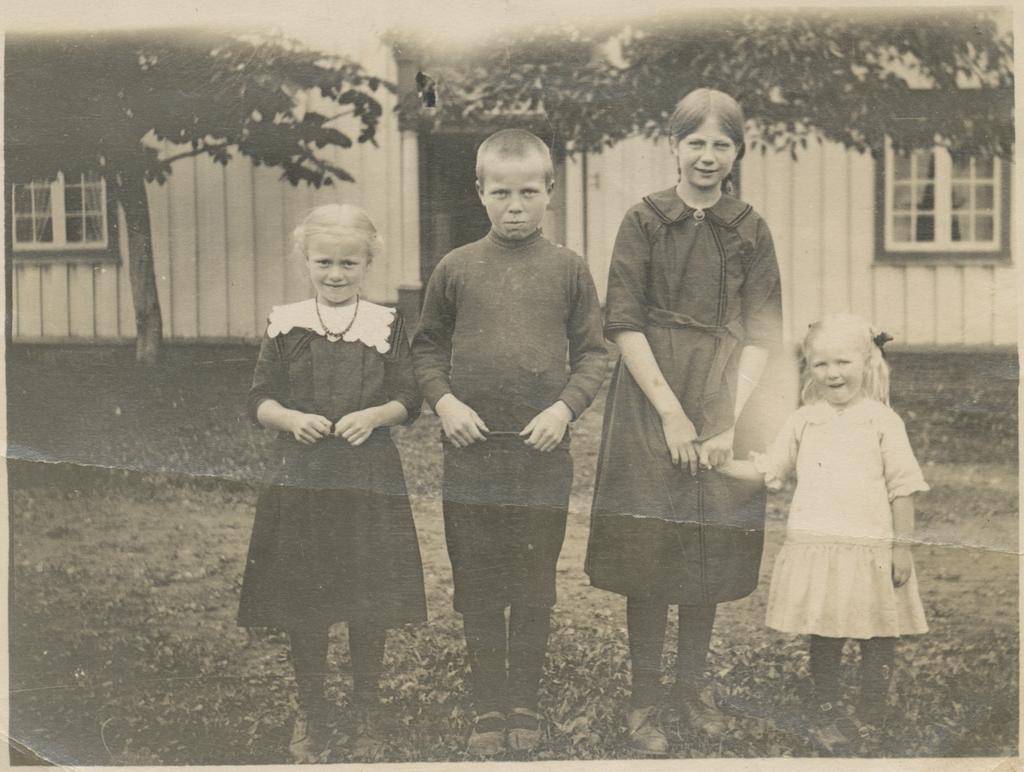Can you describe this image briefly? In this picture there are four people standing. At the back there is a building and there are trees. At the bottom there is grass. 